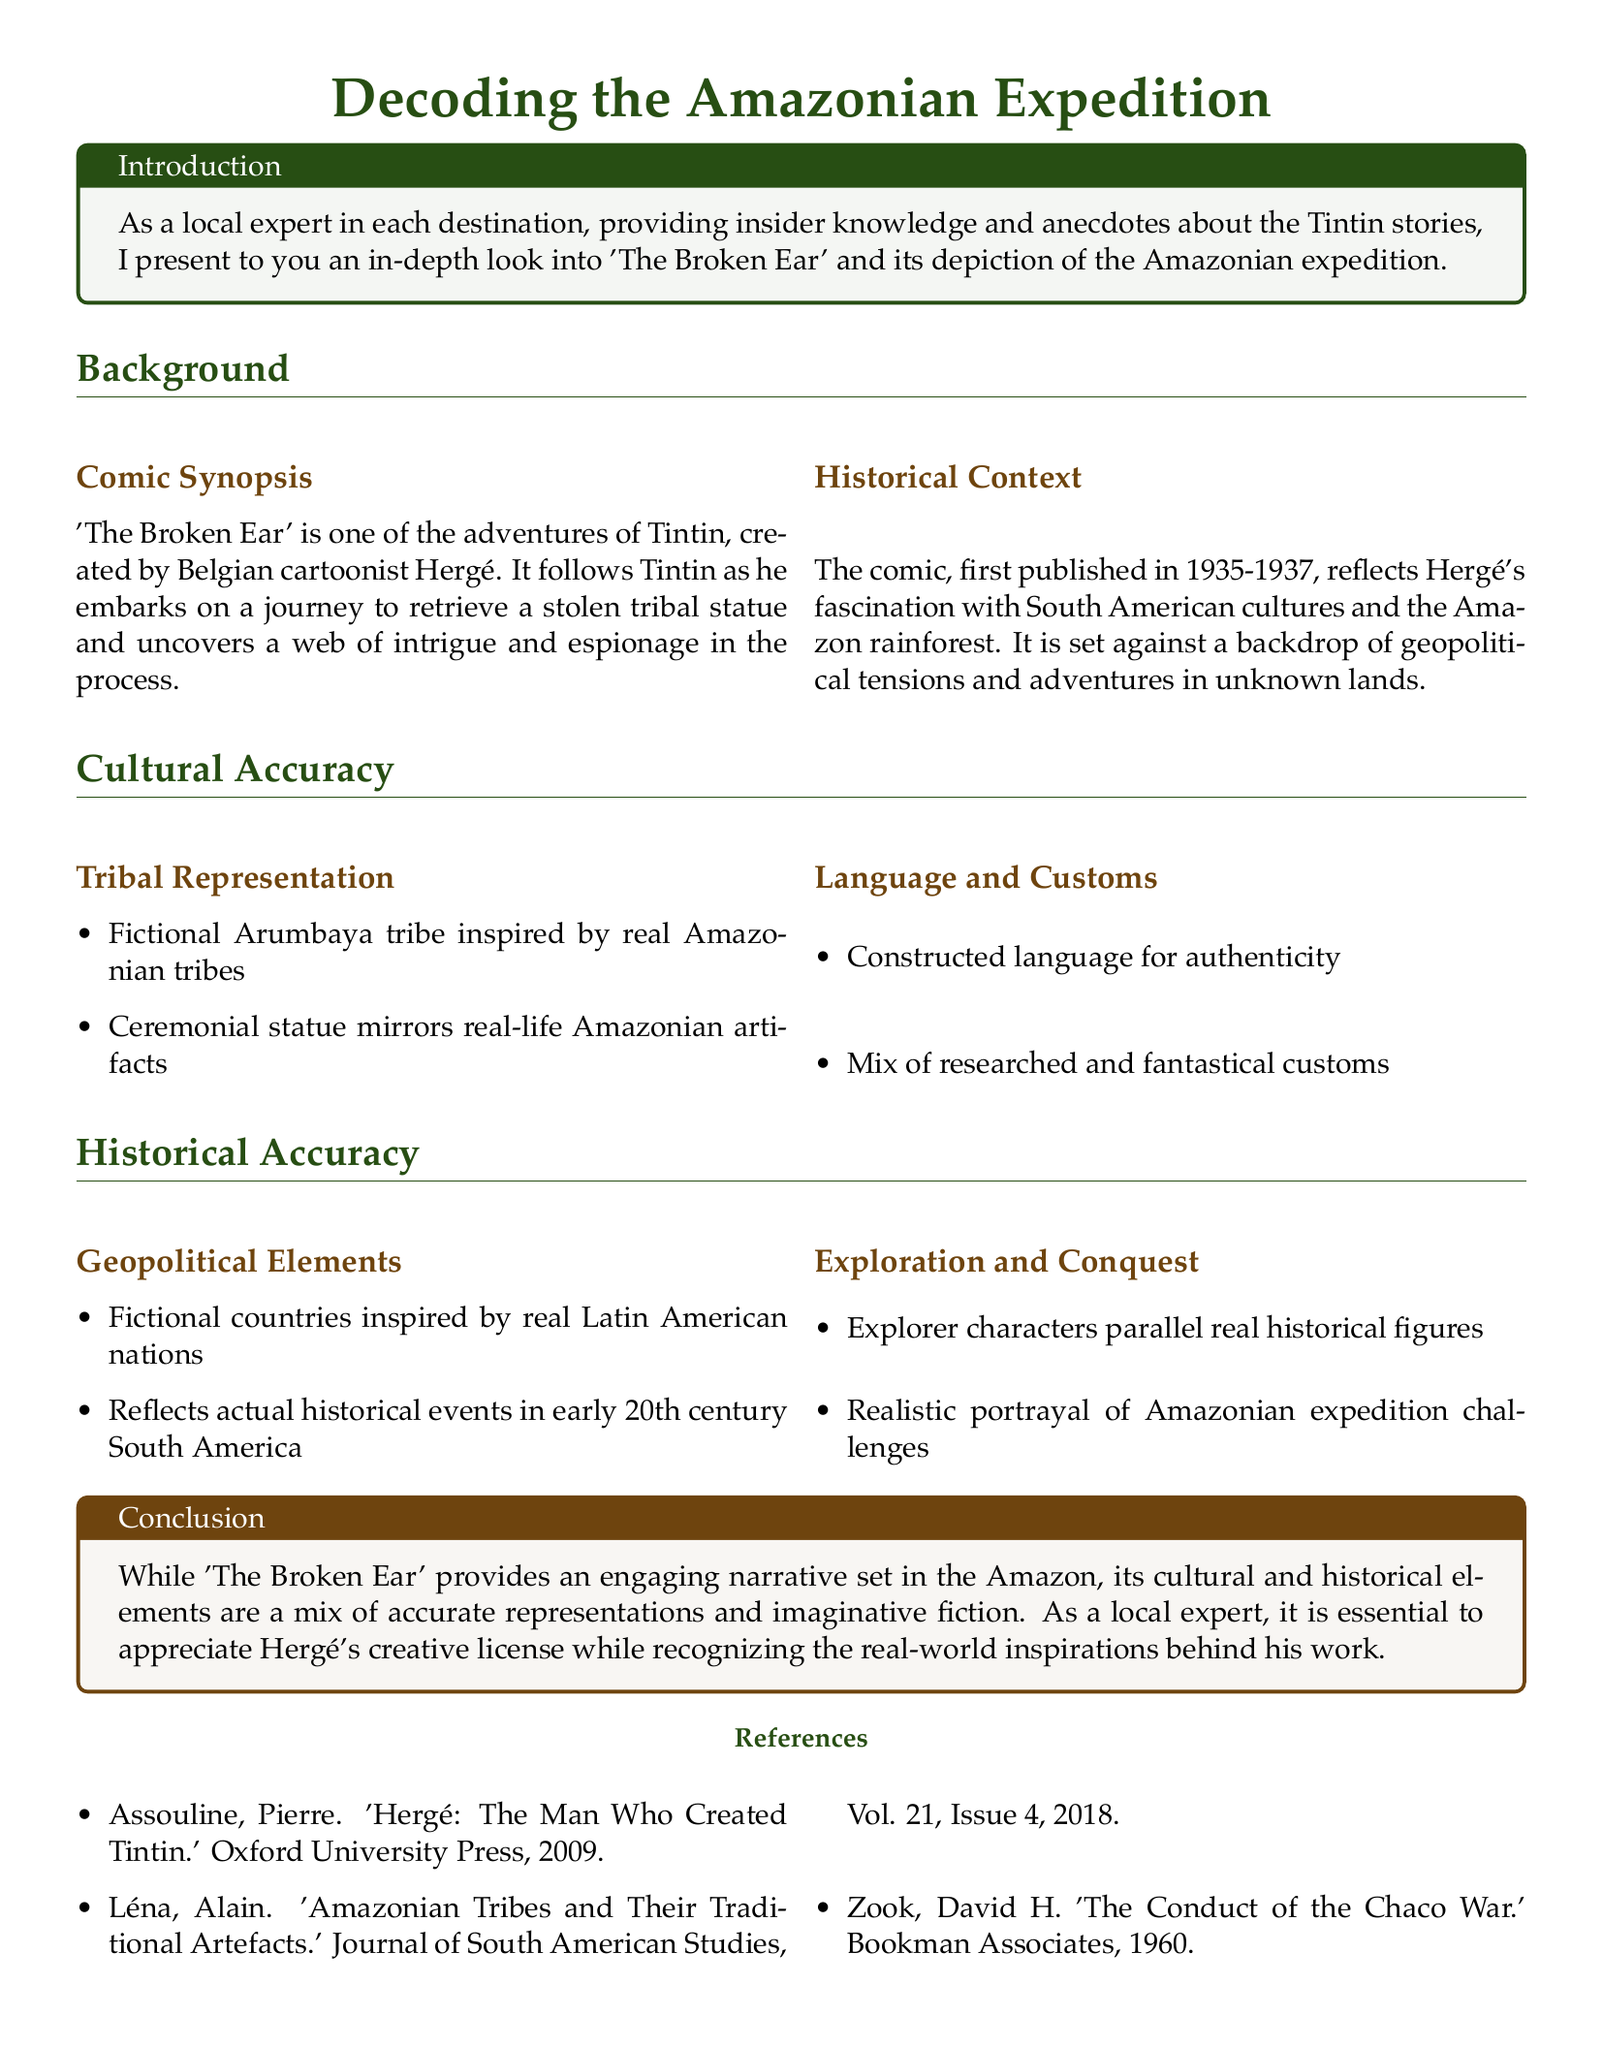What is the title of the case study? The title is presented at the top of the rendered document.
Answer: Decoding the Amazonian Expedition Who created 'The Broken Ear'? The author of the comic is mentioned in the background section of the document.
Answer: Hergé In what years was 'The Broken Ear' first published? The years of publication are specified in the historical context section.
Answer: 1935-1937 What is the fictional tribe mentioned in the comic? The tribe is highlighted under the cultural accuracy section of the document.
Answer: Arumbaya What type of challenges does Tintin face in the Amazon? The challenges faced during the expedition are detailed in the historical accuracy section.
Answer: Expedition challenges Which two colors are used in the title formatting? The colors mentioned in the document code for titles are explicitly defined.
Answer: amazongreen and earthbrown What does the ceremonial statue in the story mirror? This detail is provided under tribal representation in the cultural accuracy section.
Answer: Real-life Amazonian artifacts What is the purpose of the case study? The introduction clears the purpose of the document.
Answer: Analyzing the cultural and historical accuracy in 'The Broken Ear' 